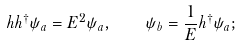<formula> <loc_0><loc_0><loc_500><loc_500>h h ^ { \dag } \psi _ { a } = E ^ { 2 } \psi _ { a } , \quad \psi _ { b } = \frac { 1 } { E } h ^ { \dag } \psi _ { a } ;</formula> 